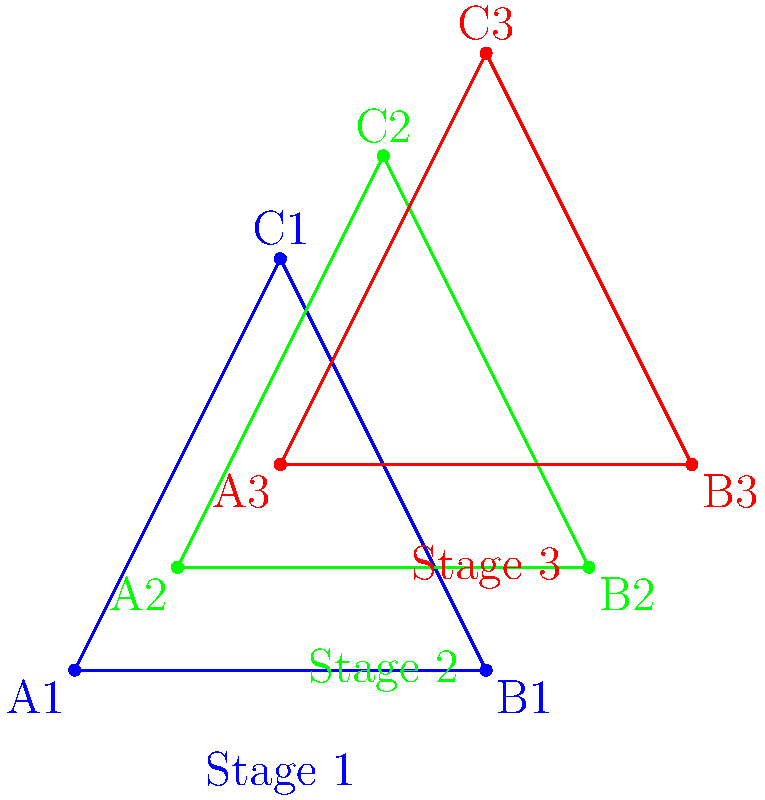In a dental treatment plan for teeth straightening, the progression of a patient's teeth alignment is modeled using transformational geometry. The blue triangle represents the initial position of three key teeth, the green triangle shows an intermediate stage, and the red triangle represents the final desired position. Assuming the transformation from Stage 1 to Stage 2 is a translation followed by a dilation, and the transformation from Stage 2 to Stage 3 is another translation, determine the composite transformation that directly maps the blue triangle (Stage 1) to the red triangle (Stage 3). Express your answer in terms of a translation vector and a scale factor. Let's approach this step-by-step:

1) First, let's analyze the transformation from Stage 1 (blue) to Stage 2 (green):
   a) Translation: The triangle appears to be shifted by vector $\vec{v_1} = (0.5, 0.5)$
   b) Dilation: The triangle is enlarged. We can calculate the scale factor by comparing side lengths:
      Scale factor $k = \frac{|A_2B_2|}{|A_1B_1|} = \frac{2}{2} = 1$ (no change in size)

2) Now, let's look at the transformation from Stage 2 (green) to Stage 3 (red):
   Translation: The triangle is shifted by vector $\vec{v_2} = (0.5, 0.5)$

3) To get the composite transformation from Stage 1 to Stage 3:
   a) Total translation vector: $\vec{v} = \vec{v_1} + \vec{v_2} = (0.5, 0.5) + (0.5, 0.5) = (1, 1)$
   b) Total dilation: The scale factor remains 1 as there was no dilation from Stage 2 to Stage 3

4) Therefore, the composite transformation can be described as:
   - A translation by vector $(1, 1)$
   - Followed by (or preceded by) a dilation with scale factor 1 (which effectively does nothing)
Answer: Translation by vector $(1, 1)$, scale factor 1 